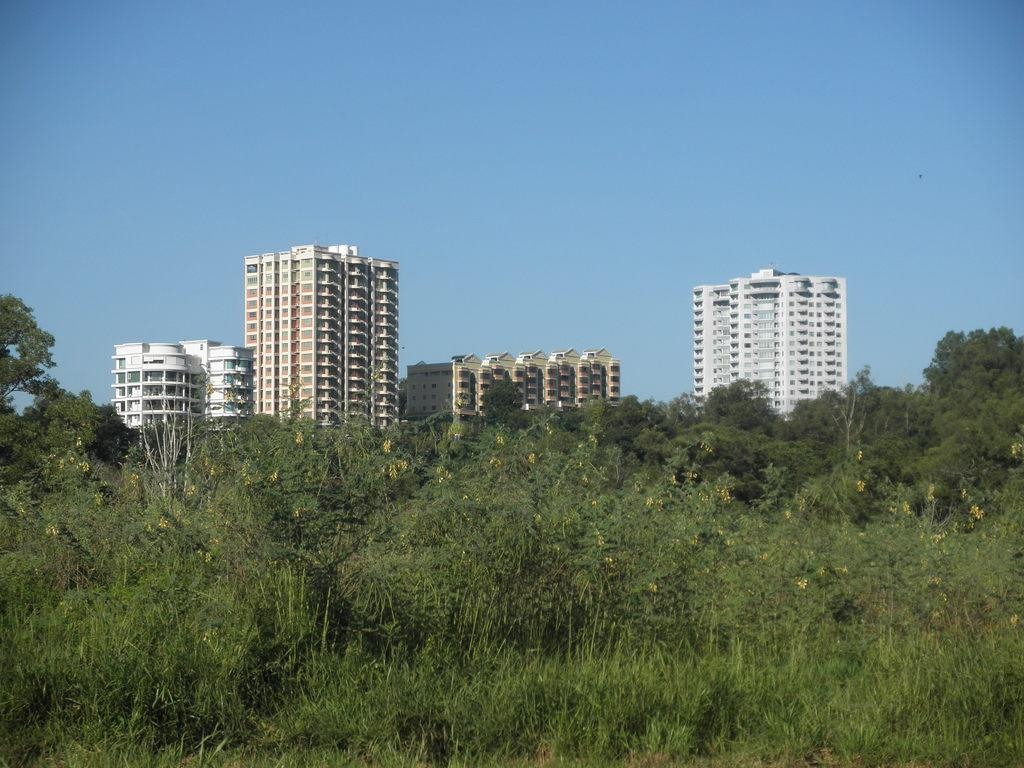What type of vegetation is present in the image? There is a lot of grass in the image. Are there any other natural elements in the image besides grass? Yes, there are trees in the image. What can be seen in the background of the image? There are four big buildings in the background of the image. What language is being spoken by the grass in the image? Grass does not speak any language, so this question cannot be answered. 